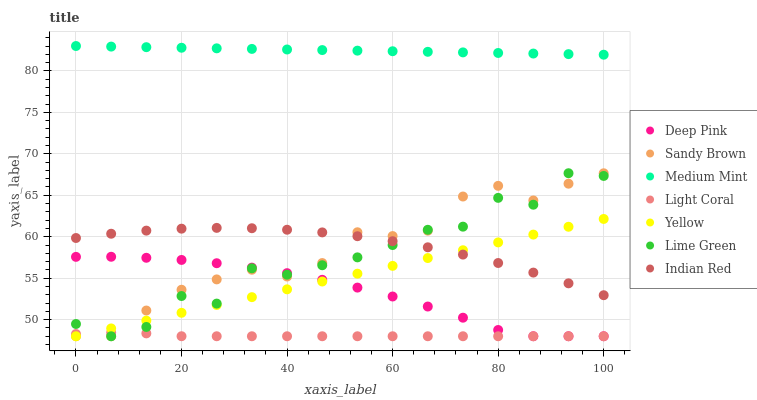Does Light Coral have the minimum area under the curve?
Answer yes or no. Yes. Does Medium Mint have the maximum area under the curve?
Answer yes or no. Yes. Does Deep Pink have the minimum area under the curve?
Answer yes or no. No. Does Deep Pink have the maximum area under the curve?
Answer yes or no. No. Is Yellow the smoothest?
Answer yes or no. Yes. Is Lime Green the roughest?
Answer yes or no. Yes. Is Deep Pink the smoothest?
Answer yes or no. No. Is Deep Pink the roughest?
Answer yes or no. No. Does Deep Pink have the lowest value?
Answer yes or no. Yes. Does Indian Red have the lowest value?
Answer yes or no. No. Does Medium Mint have the highest value?
Answer yes or no. Yes. Does Deep Pink have the highest value?
Answer yes or no. No. Is Yellow less than Medium Mint?
Answer yes or no. Yes. Is Medium Mint greater than Yellow?
Answer yes or no. Yes. Does Light Coral intersect Yellow?
Answer yes or no. Yes. Is Light Coral less than Yellow?
Answer yes or no. No. Is Light Coral greater than Yellow?
Answer yes or no. No. Does Yellow intersect Medium Mint?
Answer yes or no. No. 